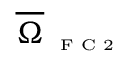Convert formula to latex. <formula><loc_0><loc_0><loc_500><loc_500>\overline { \Omega } _ { F C 2 }</formula> 